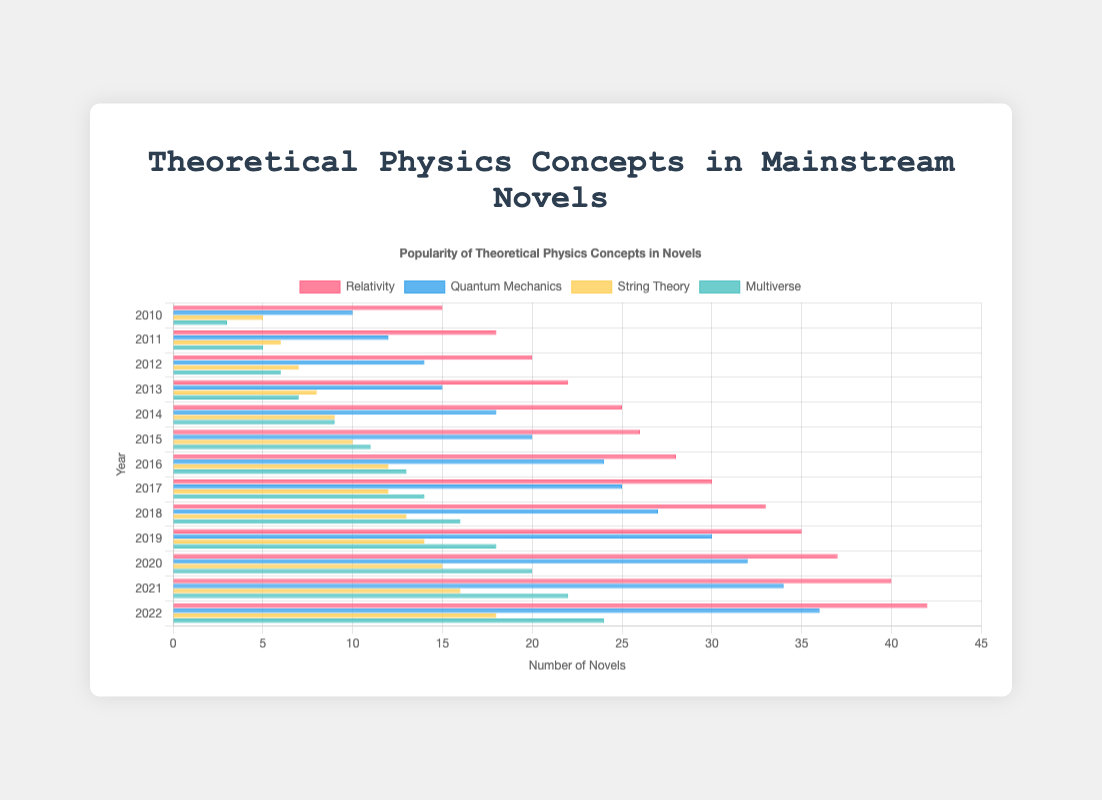Which concept saw the most significant increase in popularity from 2015 to 2022? To find the concept with the most significant increase in popularity, calculate the difference between the 2022 and 2015 values for each concept. Relativity: 42 - 26 = 16, Quantum Mechanics: 36 - 20 = 16, String Theory: 18 - 10 = 8, Multiverse: 24 - 11 = 13. Relativity and Quantum Mechanics tied for the most significant increase.
Answer: Relativity and Quantum Mechanics In which year was relativity most popular? Look at the data for relativity across all years and identify the year with the highest number. Relativity is most popular in 2022 with 42 novels.
Answer: 2022 How many more novels featured quantum mechanics than string theory in 2020? Subtract the number of novels featuring string theory from those featuring quantum mechanics in 2020. Quantum Mechanics: 32, String Theory: 15. Difference: 32 - 15 = 17
Answer: 17 Which concept had the least representation in 2013? Look at the values for each concept in 2013 and find the smallest one. Multiverse has the smallest value with 7 novels.
Answer: Multiverse What’s the average number of novels featuring relativity published between 2010 and 2022? Sum the count of novels featuring relativity from 2010 to 2022 and then divide by the number of years (13). Sum: 15 + 18 + 20 + 22 + 25 + 26 + 28 + 30 + 33 + 35 + 37 + 40 + 42 = 371, Average: 371 / 13 ≈ 28.54
Answer: 28.54 Which concept had a consistent increase in popularity every year from 2010 to 2022? Examine each concept's data set to find if there's an increase every year. Relativity increased every year consistently.
Answer: Relativity How many novels featured either string theory or relativity in 2021? Add the novels featuring string theory and those featuring relativity for the year 2021. String Theory: 16, Relativity: 40. Total: 16 + 40 = 56
Answer: 56 Did the multiverse concept ever surpass 20 novels in any year? Look at the data for multiverse from 2010 to 2022. In 2020, 2021, and 2022, multiverse had 20 or more novels.
Answer: Yes By how much did the popularity of quantum mechanics increase from 2010 to 2022? Subtract the number of novels featuring quantum mechanics in 2010 from the number in 2022. Quantum Mechanics: 36 (2022), 10 (2010). Increase: 36 - 10 = 26.
Answer: 26 Which concept saw the smallest increase in the number of novels from 2010 to 2022? Calculate the total increase for each concept from 2010 to 2022. Relativity: 42 - 15 = 27, Quantum Mechanics: 36 - 10 = 26, String Theory: 18 - 5 = 13, Multiverse: 24 - 3 = 21. String Theory had the smallest increase with 13.
Answer: String Theory 